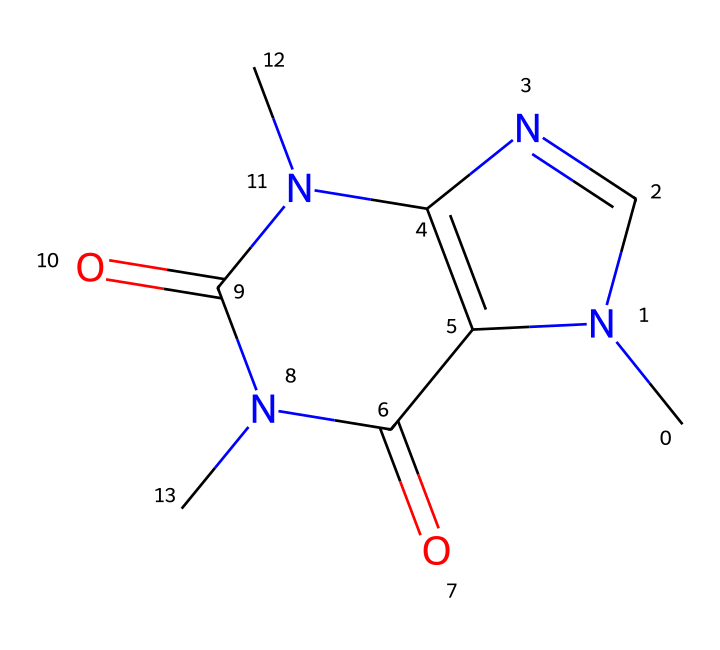What is the primary functional group in this compound? The compound contains a carbonyl group (C=O) which is evident from the notation of the double bond to oxygen. This functional group is characteristic of amides, as seen in the structure where nitrogen is bonded to the carbonyl carbon.
Answer: carbonyl How many nitrogen atoms are present in this chemical structure? By examining the SMILES representation, we can identify the two nitrogen atoms indicated by 'N' in the structure. Both are part of rings that form part of the compound's bicyclic nature.
Answer: two What type of compound does this structure represent? The presence of nitrogen and carbonyl groups suggests that this structure is a derivative of purine or similar heterocyclic compound, often associated with flavor and aroma compounds in coffee.
Answer: aromatic compound Does this compound contain rings in its structure? Observing the SMILES notation, the presence of numbers indicates bonding that forms rings. This structure distinctly incorporates two fused rings—one being a five-membered ring and the other a six-membered ring.
Answer: yes How many carbon atoms are present in the compound? By counting the 'C's in the SMILES representation and considering those in the rings, we find there are a total of six carbon atoms in this chemical structure.
Answer: six 